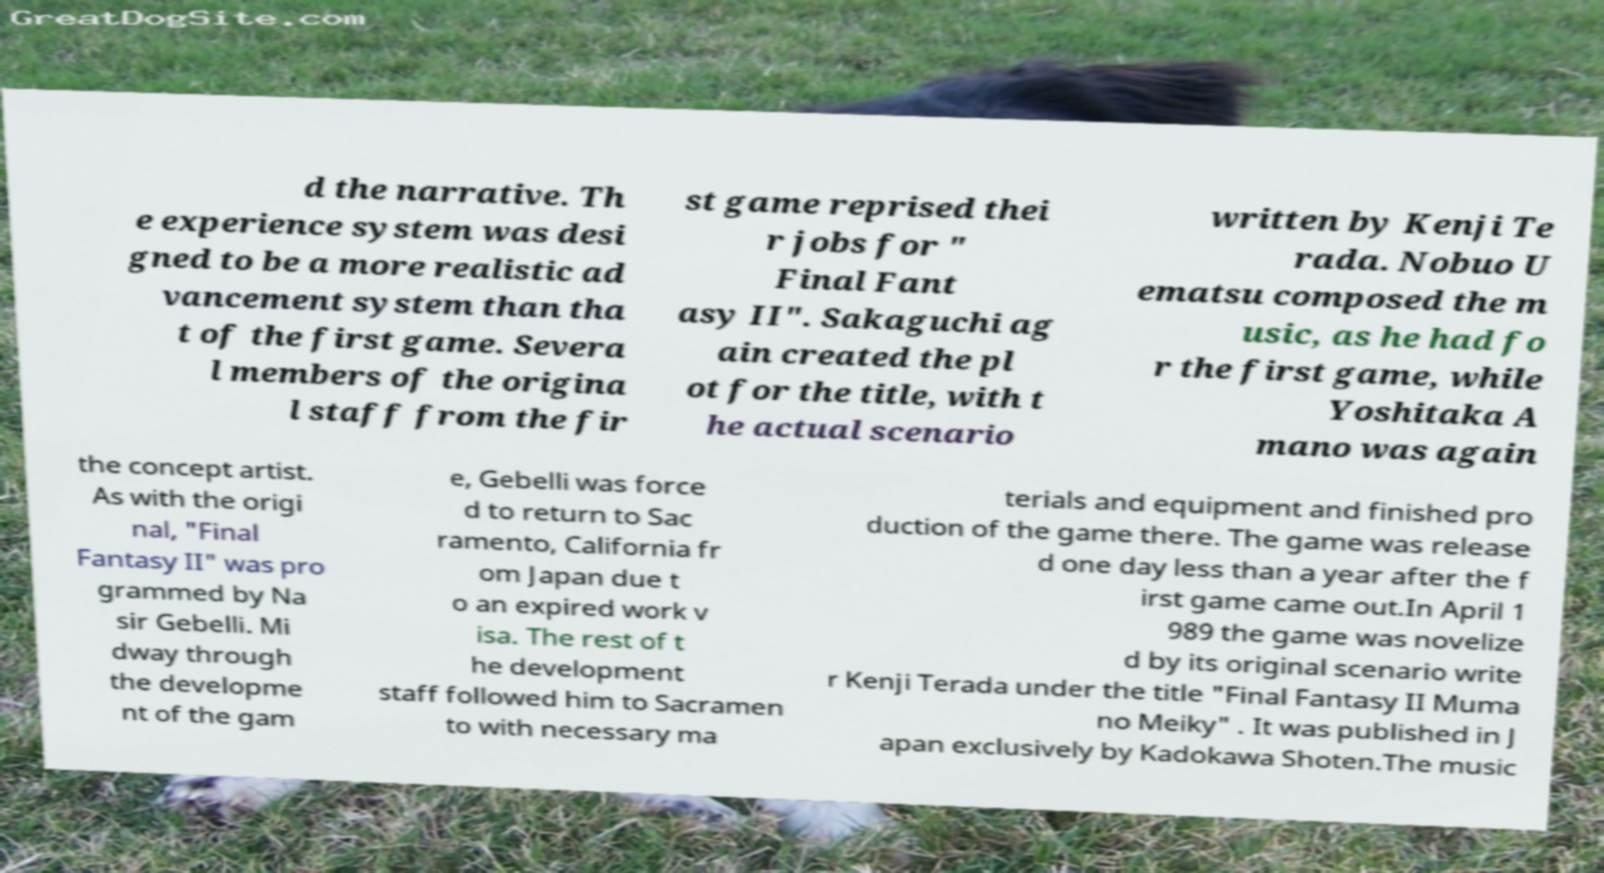There's text embedded in this image that I need extracted. Can you transcribe it verbatim? d the narrative. Th e experience system was desi gned to be a more realistic ad vancement system than tha t of the first game. Severa l members of the origina l staff from the fir st game reprised thei r jobs for " Final Fant asy II". Sakaguchi ag ain created the pl ot for the title, with t he actual scenario written by Kenji Te rada. Nobuo U ematsu composed the m usic, as he had fo r the first game, while Yoshitaka A mano was again the concept artist. As with the origi nal, "Final Fantasy II" was pro grammed by Na sir Gebelli. Mi dway through the developme nt of the gam e, Gebelli was force d to return to Sac ramento, California fr om Japan due t o an expired work v isa. The rest of t he development staff followed him to Sacramen to with necessary ma terials and equipment and finished pro duction of the game there. The game was release d one day less than a year after the f irst game came out.In April 1 989 the game was novelize d by its original scenario write r Kenji Terada under the title "Final Fantasy II Muma no Meiky" . It was published in J apan exclusively by Kadokawa Shoten.The music 